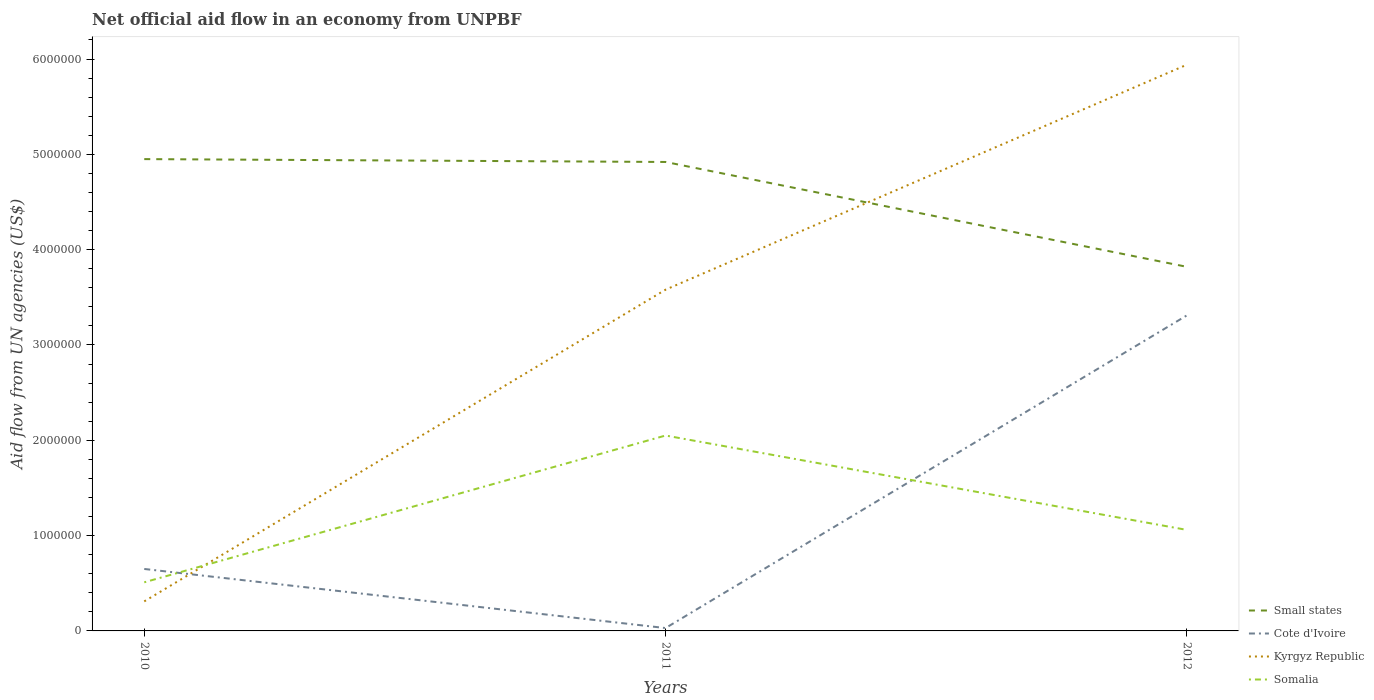How many different coloured lines are there?
Provide a short and direct response. 4. Does the line corresponding to Kyrgyz Republic intersect with the line corresponding to Somalia?
Your response must be concise. Yes. Is the number of lines equal to the number of legend labels?
Your answer should be compact. Yes. Across all years, what is the maximum net official aid flow in Small states?
Offer a very short reply. 3.82e+06. In which year was the net official aid flow in Small states maximum?
Provide a succinct answer. 2012. What is the total net official aid flow in Cote d'Ivoire in the graph?
Provide a short and direct response. -3.28e+06. What is the difference between the highest and the second highest net official aid flow in Somalia?
Provide a short and direct response. 1.54e+06. Is the net official aid flow in Kyrgyz Republic strictly greater than the net official aid flow in Cote d'Ivoire over the years?
Provide a short and direct response. No. How many years are there in the graph?
Ensure brevity in your answer.  3. Are the values on the major ticks of Y-axis written in scientific E-notation?
Make the answer very short. No. Does the graph contain any zero values?
Offer a terse response. No. Does the graph contain grids?
Offer a terse response. No. Where does the legend appear in the graph?
Give a very brief answer. Bottom right. How are the legend labels stacked?
Provide a succinct answer. Vertical. What is the title of the graph?
Provide a short and direct response. Net official aid flow in an economy from UNPBF. Does "Algeria" appear as one of the legend labels in the graph?
Provide a succinct answer. No. What is the label or title of the X-axis?
Provide a succinct answer. Years. What is the label or title of the Y-axis?
Provide a succinct answer. Aid flow from UN agencies (US$). What is the Aid flow from UN agencies (US$) of Small states in 2010?
Offer a very short reply. 4.95e+06. What is the Aid flow from UN agencies (US$) in Cote d'Ivoire in 2010?
Give a very brief answer. 6.50e+05. What is the Aid flow from UN agencies (US$) in Kyrgyz Republic in 2010?
Ensure brevity in your answer.  3.10e+05. What is the Aid flow from UN agencies (US$) of Somalia in 2010?
Make the answer very short. 5.10e+05. What is the Aid flow from UN agencies (US$) in Small states in 2011?
Keep it short and to the point. 4.92e+06. What is the Aid flow from UN agencies (US$) of Cote d'Ivoire in 2011?
Your response must be concise. 3.00e+04. What is the Aid flow from UN agencies (US$) in Kyrgyz Republic in 2011?
Make the answer very short. 3.58e+06. What is the Aid flow from UN agencies (US$) in Somalia in 2011?
Provide a short and direct response. 2.05e+06. What is the Aid flow from UN agencies (US$) of Small states in 2012?
Offer a terse response. 3.82e+06. What is the Aid flow from UN agencies (US$) of Cote d'Ivoire in 2012?
Offer a very short reply. 3.31e+06. What is the Aid flow from UN agencies (US$) of Kyrgyz Republic in 2012?
Ensure brevity in your answer.  5.94e+06. What is the Aid flow from UN agencies (US$) in Somalia in 2012?
Offer a terse response. 1.06e+06. Across all years, what is the maximum Aid flow from UN agencies (US$) in Small states?
Provide a succinct answer. 4.95e+06. Across all years, what is the maximum Aid flow from UN agencies (US$) of Cote d'Ivoire?
Give a very brief answer. 3.31e+06. Across all years, what is the maximum Aid flow from UN agencies (US$) in Kyrgyz Republic?
Your answer should be compact. 5.94e+06. Across all years, what is the maximum Aid flow from UN agencies (US$) of Somalia?
Give a very brief answer. 2.05e+06. Across all years, what is the minimum Aid flow from UN agencies (US$) in Small states?
Your answer should be compact. 3.82e+06. Across all years, what is the minimum Aid flow from UN agencies (US$) of Cote d'Ivoire?
Offer a very short reply. 3.00e+04. Across all years, what is the minimum Aid flow from UN agencies (US$) in Somalia?
Provide a succinct answer. 5.10e+05. What is the total Aid flow from UN agencies (US$) of Small states in the graph?
Keep it short and to the point. 1.37e+07. What is the total Aid flow from UN agencies (US$) in Cote d'Ivoire in the graph?
Your answer should be compact. 3.99e+06. What is the total Aid flow from UN agencies (US$) of Kyrgyz Republic in the graph?
Offer a terse response. 9.83e+06. What is the total Aid flow from UN agencies (US$) in Somalia in the graph?
Offer a terse response. 3.62e+06. What is the difference between the Aid flow from UN agencies (US$) in Small states in 2010 and that in 2011?
Make the answer very short. 3.00e+04. What is the difference between the Aid flow from UN agencies (US$) in Cote d'Ivoire in 2010 and that in 2011?
Offer a terse response. 6.20e+05. What is the difference between the Aid flow from UN agencies (US$) in Kyrgyz Republic in 2010 and that in 2011?
Your response must be concise. -3.27e+06. What is the difference between the Aid flow from UN agencies (US$) of Somalia in 2010 and that in 2011?
Your answer should be compact. -1.54e+06. What is the difference between the Aid flow from UN agencies (US$) in Small states in 2010 and that in 2012?
Offer a very short reply. 1.13e+06. What is the difference between the Aid flow from UN agencies (US$) in Cote d'Ivoire in 2010 and that in 2012?
Your response must be concise. -2.66e+06. What is the difference between the Aid flow from UN agencies (US$) of Kyrgyz Republic in 2010 and that in 2012?
Ensure brevity in your answer.  -5.63e+06. What is the difference between the Aid flow from UN agencies (US$) in Somalia in 2010 and that in 2012?
Keep it short and to the point. -5.50e+05. What is the difference between the Aid flow from UN agencies (US$) in Small states in 2011 and that in 2012?
Provide a short and direct response. 1.10e+06. What is the difference between the Aid flow from UN agencies (US$) of Cote d'Ivoire in 2011 and that in 2012?
Make the answer very short. -3.28e+06. What is the difference between the Aid flow from UN agencies (US$) of Kyrgyz Republic in 2011 and that in 2012?
Give a very brief answer. -2.36e+06. What is the difference between the Aid flow from UN agencies (US$) in Somalia in 2011 and that in 2012?
Make the answer very short. 9.90e+05. What is the difference between the Aid flow from UN agencies (US$) of Small states in 2010 and the Aid flow from UN agencies (US$) of Cote d'Ivoire in 2011?
Your response must be concise. 4.92e+06. What is the difference between the Aid flow from UN agencies (US$) of Small states in 2010 and the Aid flow from UN agencies (US$) of Kyrgyz Republic in 2011?
Your answer should be very brief. 1.37e+06. What is the difference between the Aid flow from UN agencies (US$) in Small states in 2010 and the Aid flow from UN agencies (US$) in Somalia in 2011?
Offer a very short reply. 2.90e+06. What is the difference between the Aid flow from UN agencies (US$) of Cote d'Ivoire in 2010 and the Aid flow from UN agencies (US$) of Kyrgyz Republic in 2011?
Your answer should be compact. -2.93e+06. What is the difference between the Aid flow from UN agencies (US$) in Cote d'Ivoire in 2010 and the Aid flow from UN agencies (US$) in Somalia in 2011?
Provide a short and direct response. -1.40e+06. What is the difference between the Aid flow from UN agencies (US$) in Kyrgyz Republic in 2010 and the Aid flow from UN agencies (US$) in Somalia in 2011?
Keep it short and to the point. -1.74e+06. What is the difference between the Aid flow from UN agencies (US$) of Small states in 2010 and the Aid flow from UN agencies (US$) of Cote d'Ivoire in 2012?
Make the answer very short. 1.64e+06. What is the difference between the Aid flow from UN agencies (US$) of Small states in 2010 and the Aid flow from UN agencies (US$) of Kyrgyz Republic in 2012?
Provide a short and direct response. -9.90e+05. What is the difference between the Aid flow from UN agencies (US$) of Small states in 2010 and the Aid flow from UN agencies (US$) of Somalia in 2012?
Keep it short and to the point. 3.89e+06. What is the difference between the Aid flow from UN agencies (US$) in Cote d'Ivoire in 2010 and the Aid flow from UN agencies (US$) in Kyrgyz Republic in 2012?
Give a very brief answer. -5.29e+06. What is the difference between the Aid flow from UN agencies (US$) in Cote d'Ivoire in 2010 and the Aid flow from UN agencies (US$) in Somalia in 2012?
Your answer should be compact. -4.10e+05. What is the difference between the Aid flow from UN agencies (US$) of Kyrgyz Republic in 2010 and the Aid flow from UN agencies (US$) of Somalia in 2012?
Provide a succinct answer. -7.50e+05. What is the difference between the Aid flow from UN agencies (US$) of Small states in 2011 and the Aid flow from UN agencies (US$) of Cote d'Ivoire in 2012?
Offer a terse response. 1.61e+06. What is the difference between the Aid flow from UN agencies (US$) of Small states in 2011 and the Aid flow from UN agencies (US$) of Kyrgyz Republic in 2012?
Ensure brevity in your answer.  -1.02e+06. What is the difference between the Aid flow from UN agencies (US$) in Small states in 2011 and the Aid flow from UN agencies (US$) in Somalia in 2012?
Offer a very short reply. 3.86e+06. What is the difference between the Aid flow from UN agencies (US$) of Cote d'Ivoire in 2011 and the Aid flow from UN agencies (US$) of Kyrgyz Republic in 2012?
Provide a short and direct response. -5.91e+06. What is the difference between the Aid flow from UN agencies (US$) of Cote d'Ivoire in 2011 and the Aid flow from UN agencies (US$) of Somalia in 2012?
Offer a terse response. -1.03e+06. What is the difference between the Aid flow from UN agencies (US$) of Kyrgyz Republic in 2011 and the Aid flow from UN agencies (US$) of Somalia in 2012?
Offer a very short reply. 2.52e+06. What is the average Aid flow from UN agencies (US$) in Small states per year?
Offer a terse response. 4.56e+06. What is the average Aid flow from UN agencies (US$) of Cote d'Ivoire per year?
Make the answer very short. 1.33e+06. What is the average Aid flow from UN agencies (US$) in Kyrgyz Republic per year?
Ensure brevity in your answer.  3.28e+06. What is the average Aid flow from UN agencies (US$) of Somalia per year?
Offer a very short reply. 1.21e+06. In the year 2010, what is the difference between the Aid flow from UN agencies (US$) of Small states and Aid flow from UN agencies (US$) of Cote d'Ivoire?
Provide a short and direct response. 4.30e+06. In the year 2010, what is the difference between the Aid flow from UN agencies (US$) in Small states and Aid flow from UN agencies (US$) in Kyrgyz Republic?
Your response must be concise. 4.64e+06. In the year 2010, what is the difference between the Aid flow from UN agencies (US$) in Small states and Aid flow from UN agencies (US$) in Somalia?
Your answer should be compact. 4.44e+06. In the year 2010, what is the difference between the Aid flow from UN agencies (US$) in Cote d'Ivoire and Aid flow from UN agencies (US$) in Somalia?
Give a very brief answer. 1.40e+05. In the year 2011, what is the difference between the Aid flow from UN agencies (US$) in Small states and Aid flow from UN agencies (US$) in Cote d'Ivoire?
Ensure brevity in your answer.  4.89e+06. In the year 2011, what is the difference between the Aid flow from UN agencies (US$) in Small states and Aid flow from UN agencies (US$) in Kyrgyz Republic?
Offer a very short reply. 1.34e+06. In the year 2011, what is the difference between the Aid flow from UN agencies (US$) of Small states and Aid flow from UN agencies (US$) of Somalia?
Provide a succinct answer. 2.87e+06. In the year 2011, what is the difference between the Aid flow from UN agencies (US$) in Cote d'Ivoire and Aid flow from UN agencies (US$) in Kyrgyz Republic?
Provide a short and direct response. -3.55e+06. In the year 2011, what is the difference between the Aid flow from UN agencies (US$) of Cote d'Ivoire and Aid flow from UN agencies (US$) of Somalia?
Provide a short and direct response. -2.02e+06. In the year 2011, what is the difference between the Aid flow from UN agencies (US$) in Kyrgyz Republic and Aid flow from UN agencies (US$) in Somalia?
Ensure brevity in your answer.  1.53e+06. In the year 2012, what is the difference between the Aid flow from UN agencies (US$) of Small states and Aid flow from UN agencies (US$) of Cote d'Ivoire?
Provide a short and direct response. 5.10e+05. In the year 2012, what is the difference between the Aid flow from UN agencies (US$) in Small states and Aid flow from UN agencies (US$) in Kyrgyz Republic?
Offer a very short reply. -2.12e+06. In the year 2012, what is the difference between the Aid flow from UN agencies (US$) of Small states and Aid flow from UN agencies (US$) of Somalia?
Offer a terse response. 2.76e+06. In the year 2012, what is the difference between the Aid flow from UN agencies (US$) of Cote d'Ivoire and Aid flow from UN agencies (US$) of Kyrgyz Republic?
Your response must be concise. -2.63e+06. In the year 2012, what is the difference between the Aid flow from UN agencies (US$) in Cote d'Ivoire and Aid flow from UN agencies (US$) in Somalia?
Your response must be concise. 2.25e+06. In the year 2012, what is the difference between the Aid flow from UN agencies (US$) of Kyrgyz Republic and Aid flow from UN agencies (US$) of Somalia?
Your answer should be very brief. 4.88e+06. What is the ratio of the Aid flow from UN agencies (US$) in Cote d'Ivoire in 2010 to that in 2011?
Your response must be concise. 21.67. What is the ratio of the Aid flow from UN agencies (US$) in Kyrgyz Republic in 2010 to that in 2011?
Provide a short and direct response. 0.09. What is the ratio of the Aid flow from UN agencies (US$) in Somalia in 2010 to that in 2011?
Your answer should be very brief. 0.25. What is the ratio of the Aid flow from UN agencies (US$) in Small states in 2010 to that in 2012?
Provide a succinct answer. 1.3. What is the ratio of the Aid flow from UN agencies (US$) in Cote d'Ivoire in 2010 to that in 2012?
Provide a succinct answer. 0.2. What is the ratio of the Aid flow from UN agencies (US$) in Kyrgyz Republic in 2010 to that in 2012?
Keep it short and to the point. 0.05. What is the ratio of the Aid flow from UN agencies (US$) of Somalia in 2010 to that in 2012?
Make the answer very short. 0.48. What is the ratio of the Aid flow from UN agencies (US$) of Small states in 2011 to that in 2012?
Keep it short and to the point. 1.29. What is the ratio of the Aid flow from UN agencies (US$) in Cote d'Ivoire in 2011 to that in 2012?
Your answer should be very brief. 0.01. What is the ratio of the Aid flow from UN agencies (US$) of Kyrgyz Republic in 2011 to that in 2012?
Offer a very short reply. 0.6. What is the ratio of the Aid flow from UN agencies (US$) in Somalia in 2011 to that in 2012?
Make the answer very short. 1.93. What is the difference between the highest and the second highest Aid flow from UN agencies (US$) of Cote d'Ivoire?
Offer a terse response. 2.66e+06. What is the difference between the highest and the second highest Aid flow from UN agencies (US$) in Kyrgyz Republic?
Your answer should be compact. 2.36e+06. What is the difference between the highest and the second highest Aid flow from UN agencies (US$) of Somalia?
Provide a succinct answer. 9.90e+05. What is the difference between the highest and the lowest Aid flow from UN agencies (US$) in Small states?
Provide a succinct answer. 1.13e+06. What is the difference between the highest and the lowest Aid flow from UN agencies (US$) in Cote d'Ivoire?
Your answer should be compact. 3.28e+06. What is the difference between the highest and the lowest Aid flow from UN agencies (US$) of Kyrgyz Republic?
Offer a terse response. 5.63e+06. What is the difference between the highest and the lowest Aid flow from UN agencies (US$) in Somalia?
Your response must be concise. 1.54e+06. 